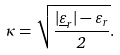<formula> <loc_0><loc_0><loc_500><loc_500>\kappa = { \sqrt { \frac { | { \underline { \varepsilon } } _ { r } | - \varepsilon _ { r } } { 2 } } } .</formula> 